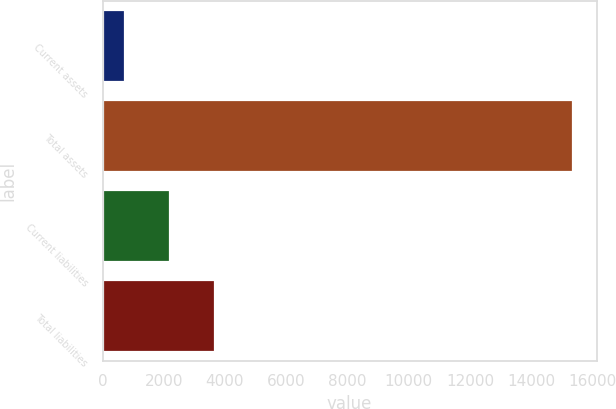Convert chart to OTSL. <chart><loc_0><loc_0><loc_500><loc_500><bar_chart><fcel>Current assets<fcel>Total assets<fcel>Current liabilities<fcel>Total liabilities<nl><fcel>751<fcel>15372<fcel>2213.1<fcel>3675.2<nl></chart> 